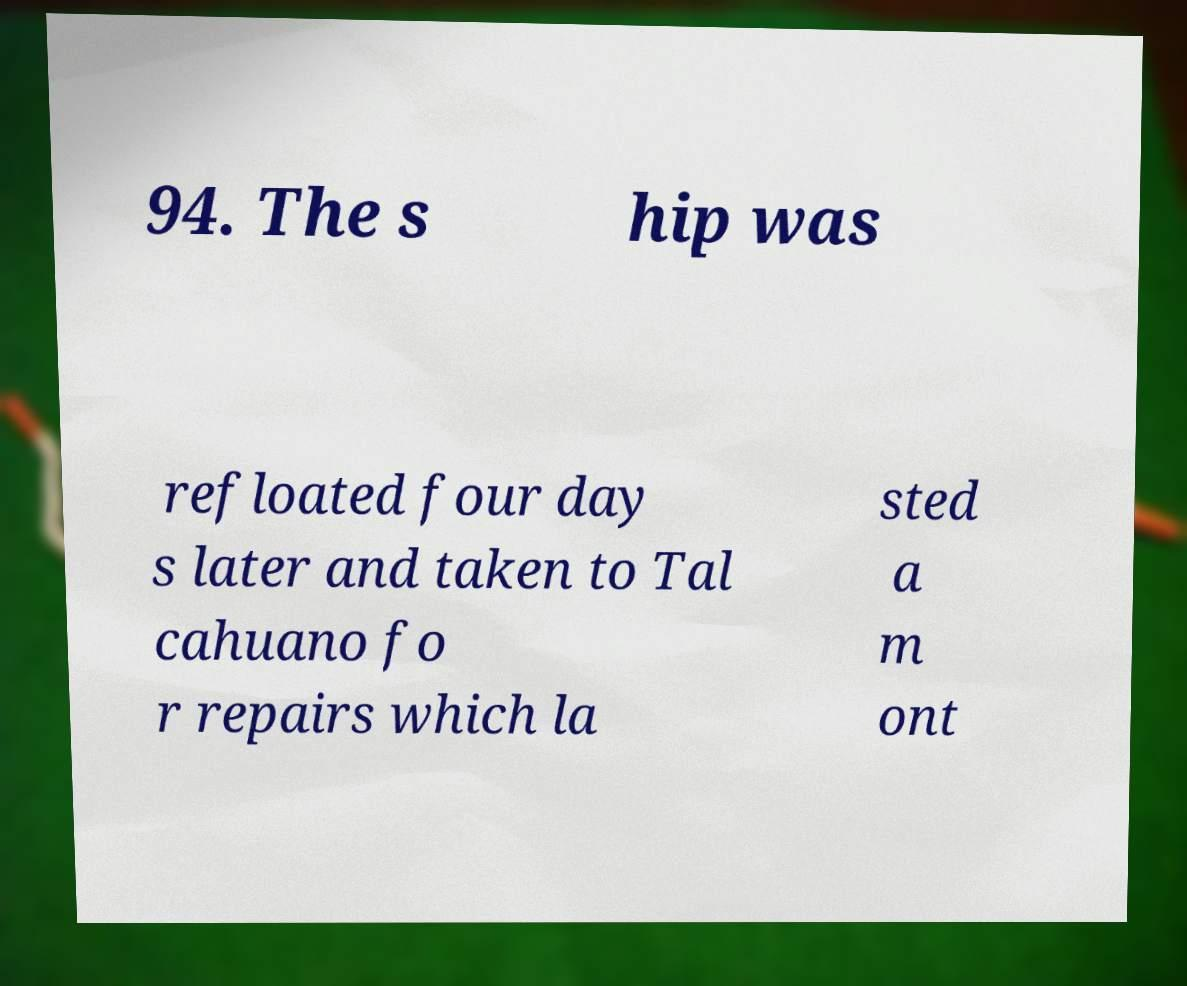For documentation purposes, I need the text within this image transcribed. Could you provide that? 94. The s hip was refloated four day s later and taken to Tal cahuano fo r repairs which la sted a m ont 